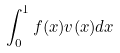<formula> <loc_0><loc_0><loc_500><loc_500>\int _ { 0 } ^ { 1 } f ( x ) v ( x ) d x</formula> 